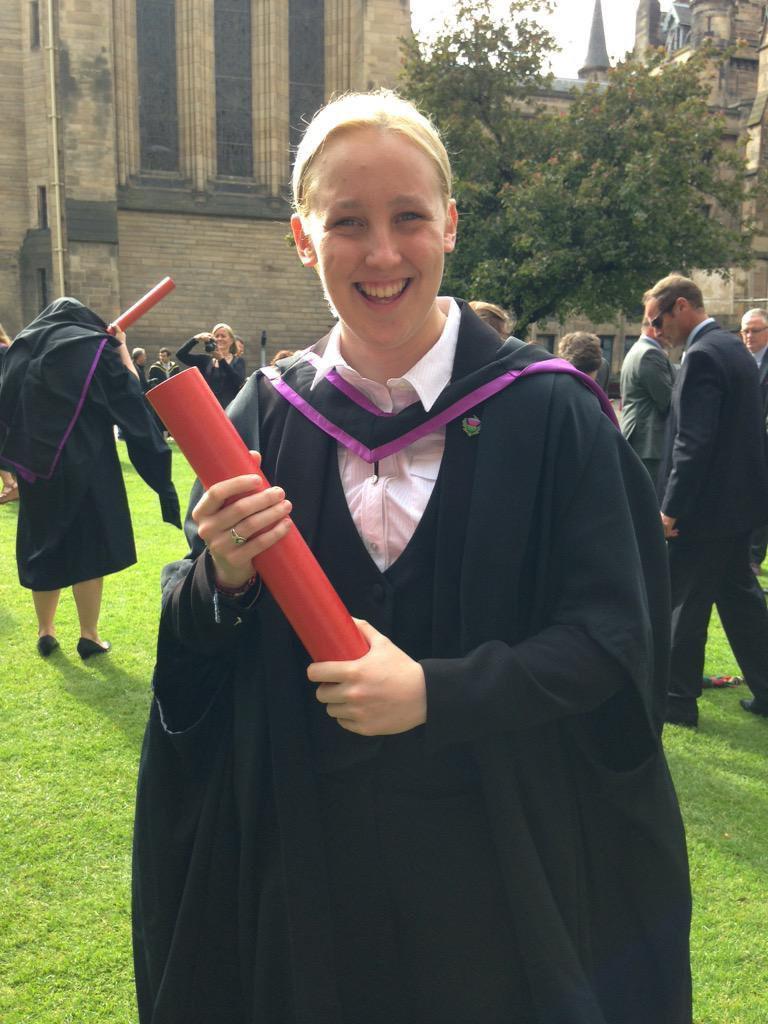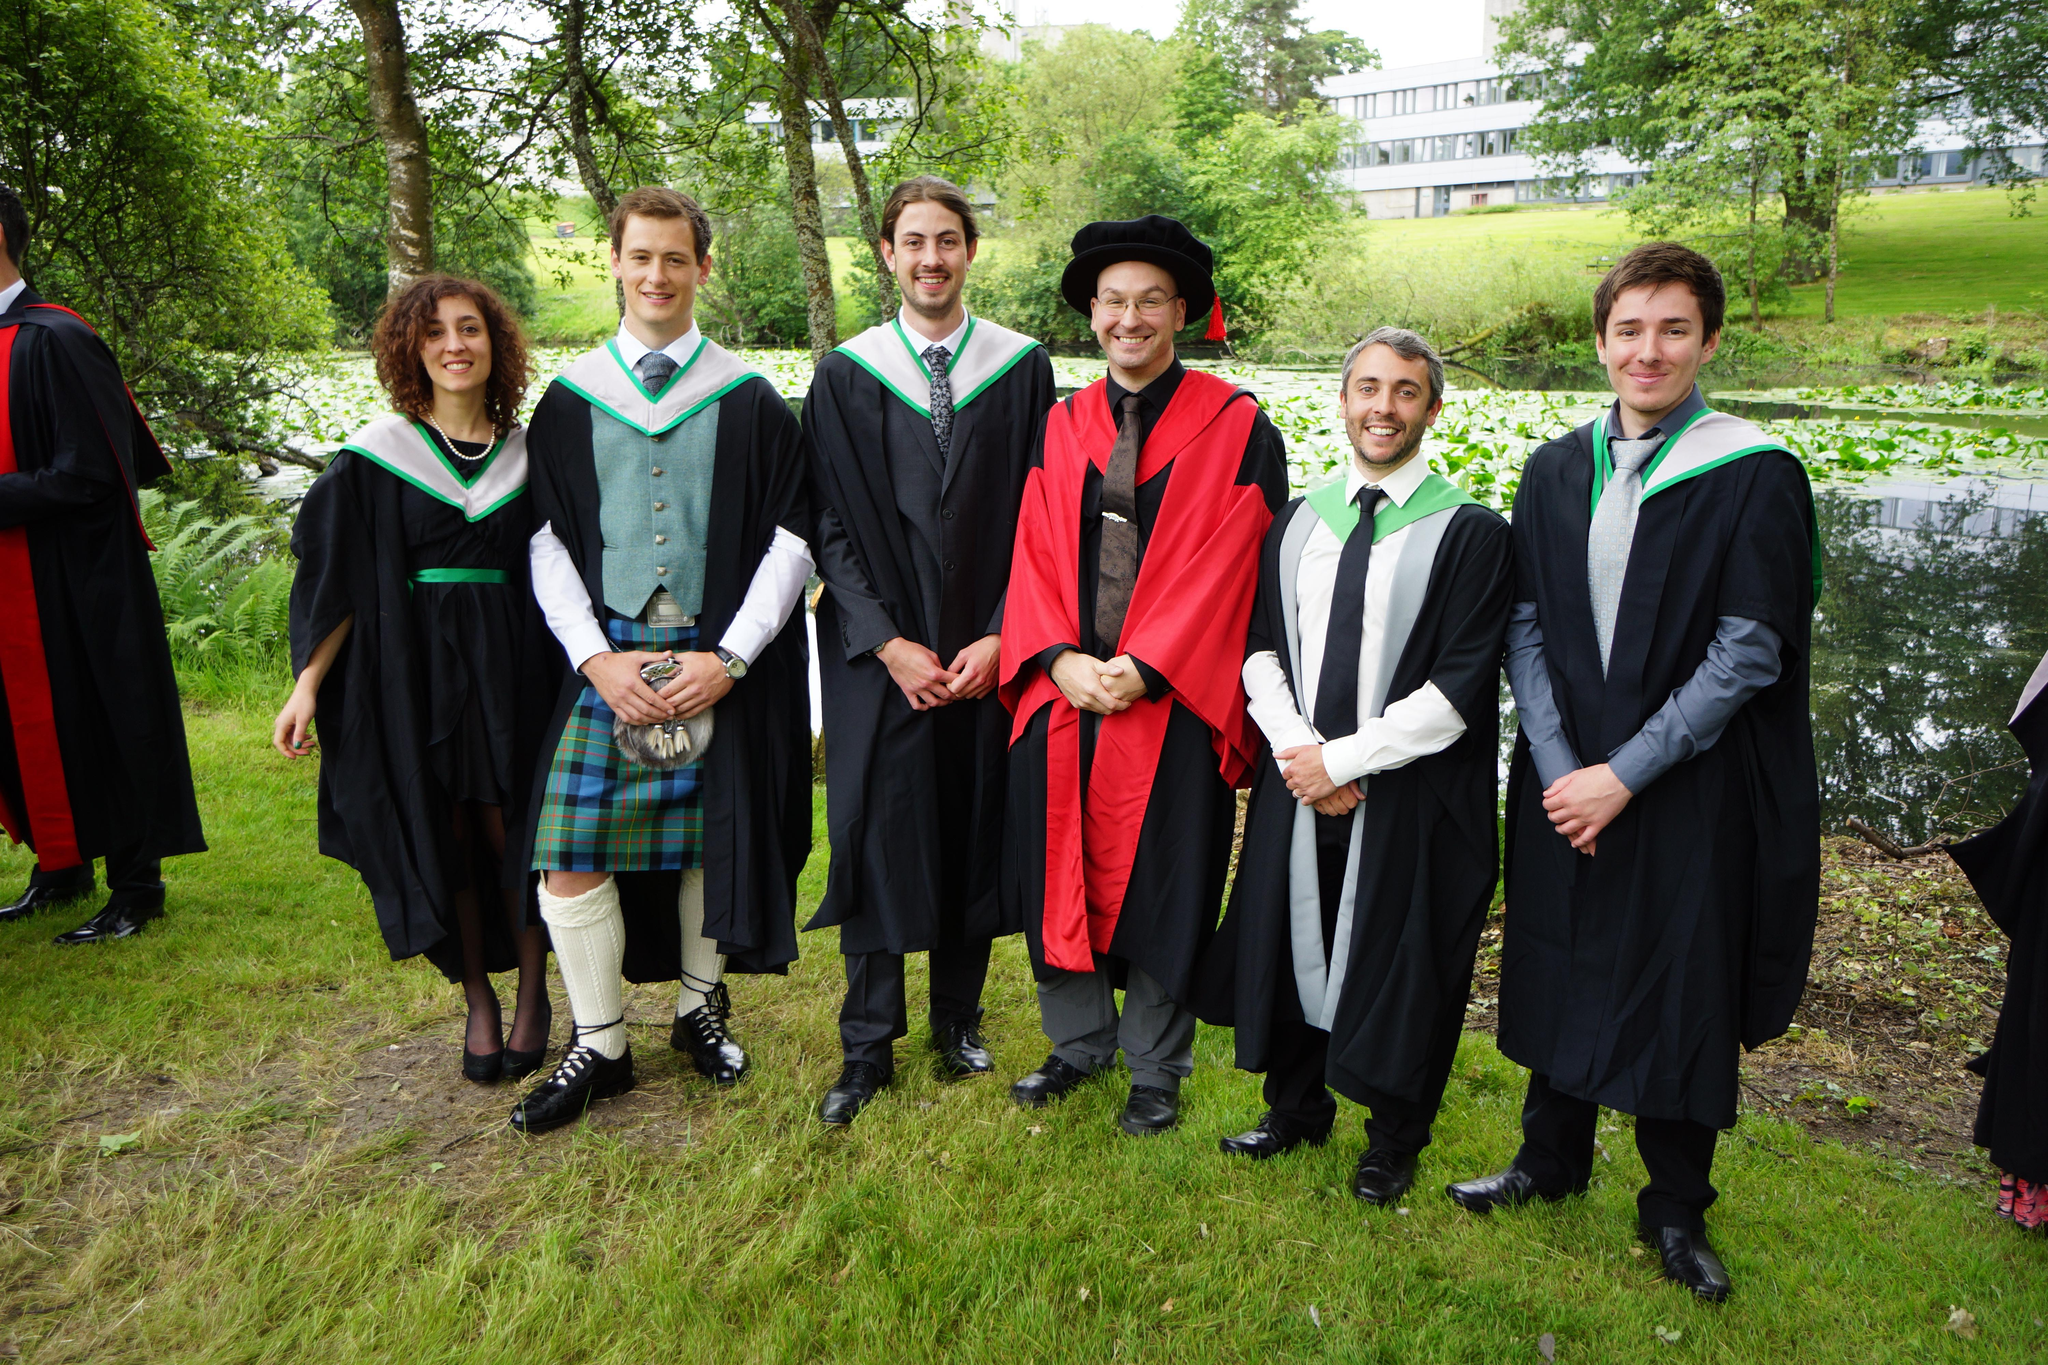The first image is the image on the left, the second image is the image on the right. For the images displayed, is the sentence "At least four people hold red tube shapes and wear black robes in the foreground of one image." factually correct? Answer yes or no. No. The first image is the image on the left, the second image is the image on the right. For the images displayed, is the sentence "At least four graduates are holding red diploma tubes." factually correct? Answer yes or no. No. 